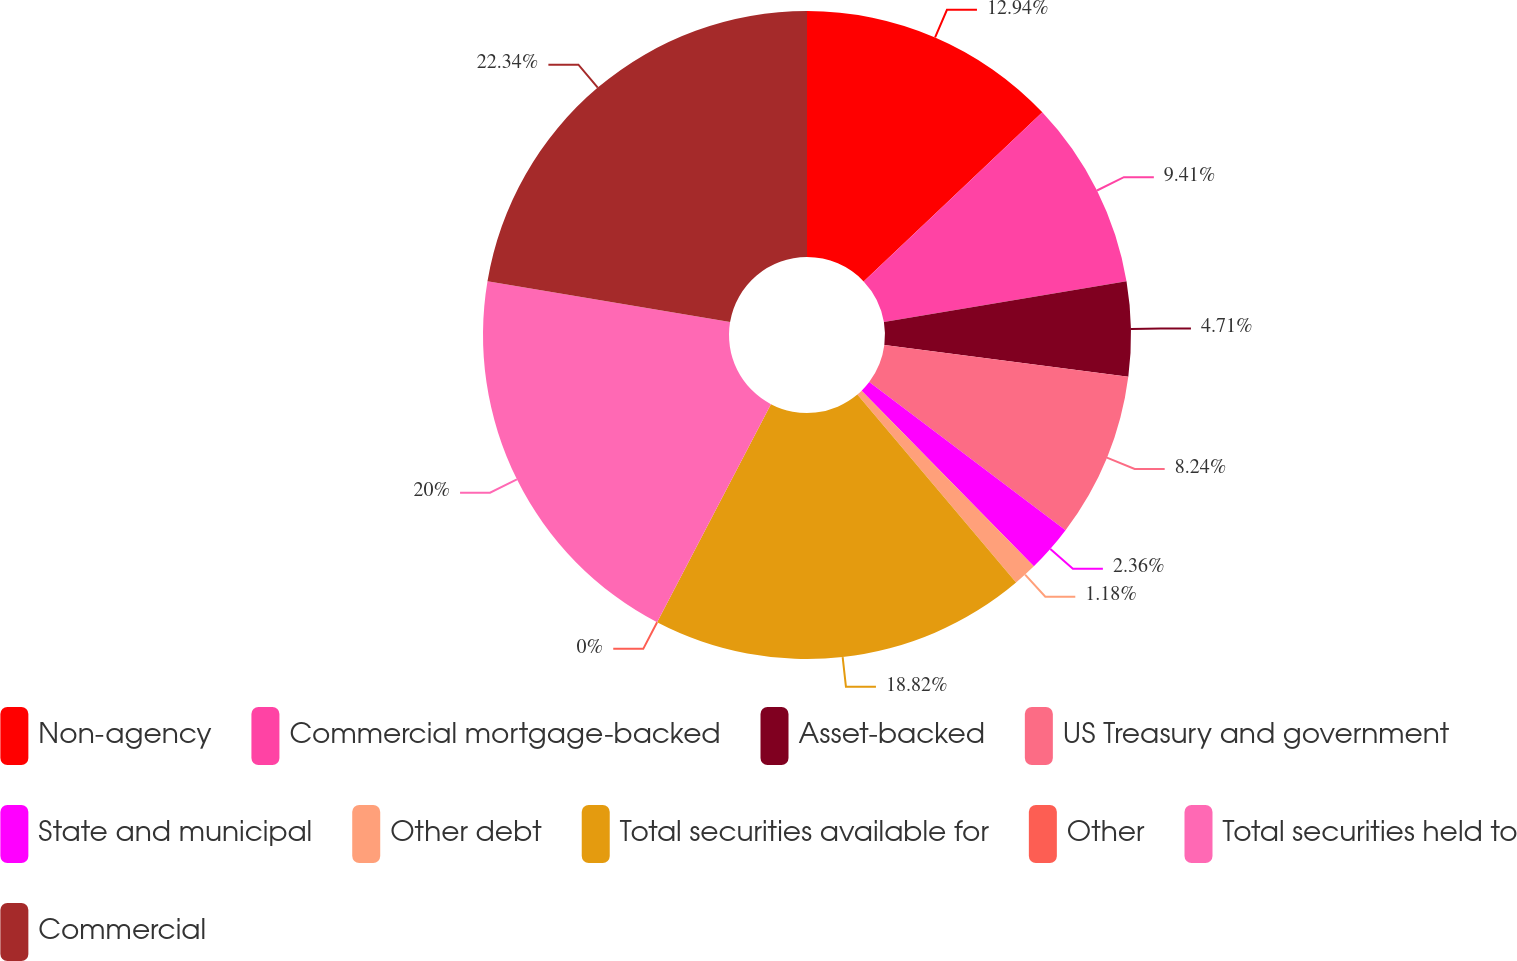<chart> <loc_0><loc_0><loc_500><loc_500><pie_chart><fcel>Non-agency<fcel>Commercial mortgage-backed<fcel>Asset-backed<fcel>US Treasury and government<fcel>State and municipal<fcel>Other debt<fcel>Total securities available for<fcel>Other<fcel>Total securities held to<fcel>Commercial<nl><fcel>12.94%<fcel>9.41%<fcel>4.71%<fcel>8.24%<fcel>2.36%<fcel>1.18%<fcel>18.82%<fcel>0.0%<fcel>20.0%<fcel>22.35%<nl></chart> 